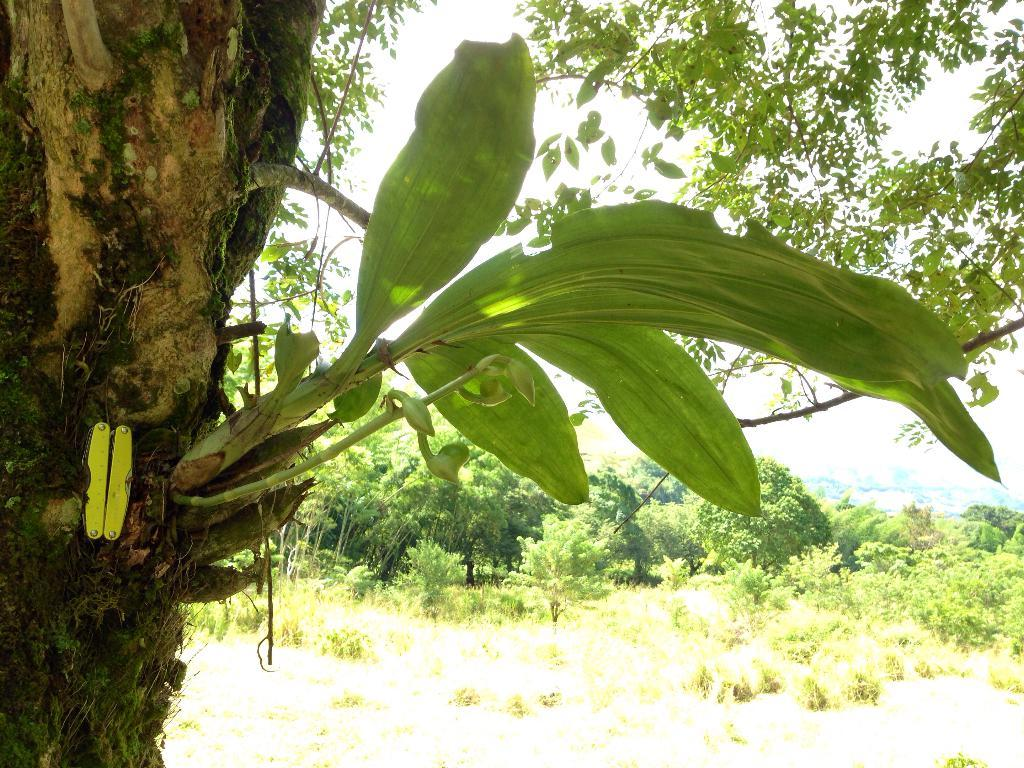What type of natural elements can be seen in the image? There are trees and plants in the image. Can you describe the tree on the left side of the image? There is a tree trunk with branches and leaves on the left side of the image. What is visible in the background of the image? The sky is visible in the background of the image. Where is the cow located in the image? There is no cow present in the image. What type of honey can be seen dripping from the tree branches? There is no honey present in the image; it features trees and plants without any honey. 